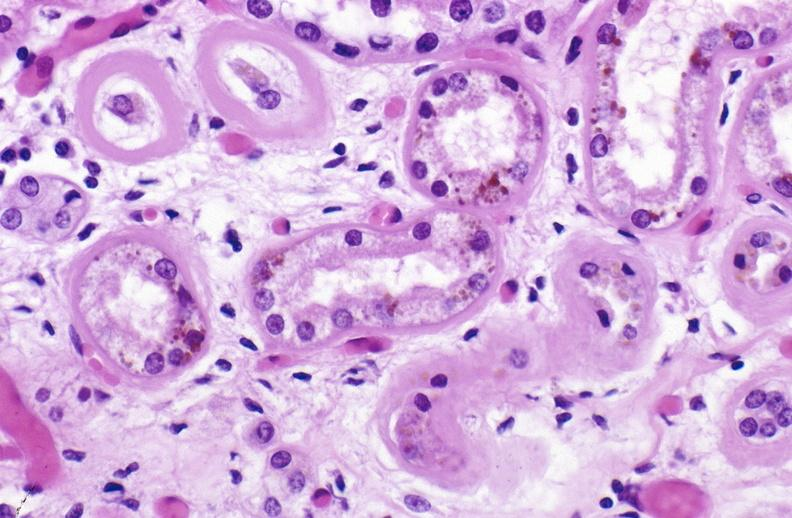where is this?
Answer the question using a single word or phrase. Urinary 